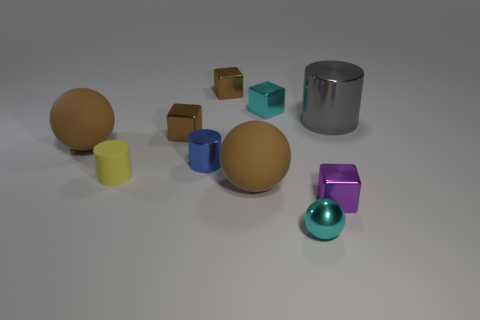Subtract all tiny cyan cubes. How many cubes are left? 3 Subtract 1 cubes. How many cubes are left? 3 Subtract all gray cubes. Subtract all green cylinders. How many cubes are left? 4 Subtract all cylinders. How many objects are left? 7 Subtract 0 yellow spheres. How many objects are left? 10 Subtract all yellow metallic things. Subtract all blue cylinders. How many objects are left? 9 Add 8 rubber balls. How many rubber balls are left? 10 Add 1 large brown balls. How many large brown balls exist? 3 